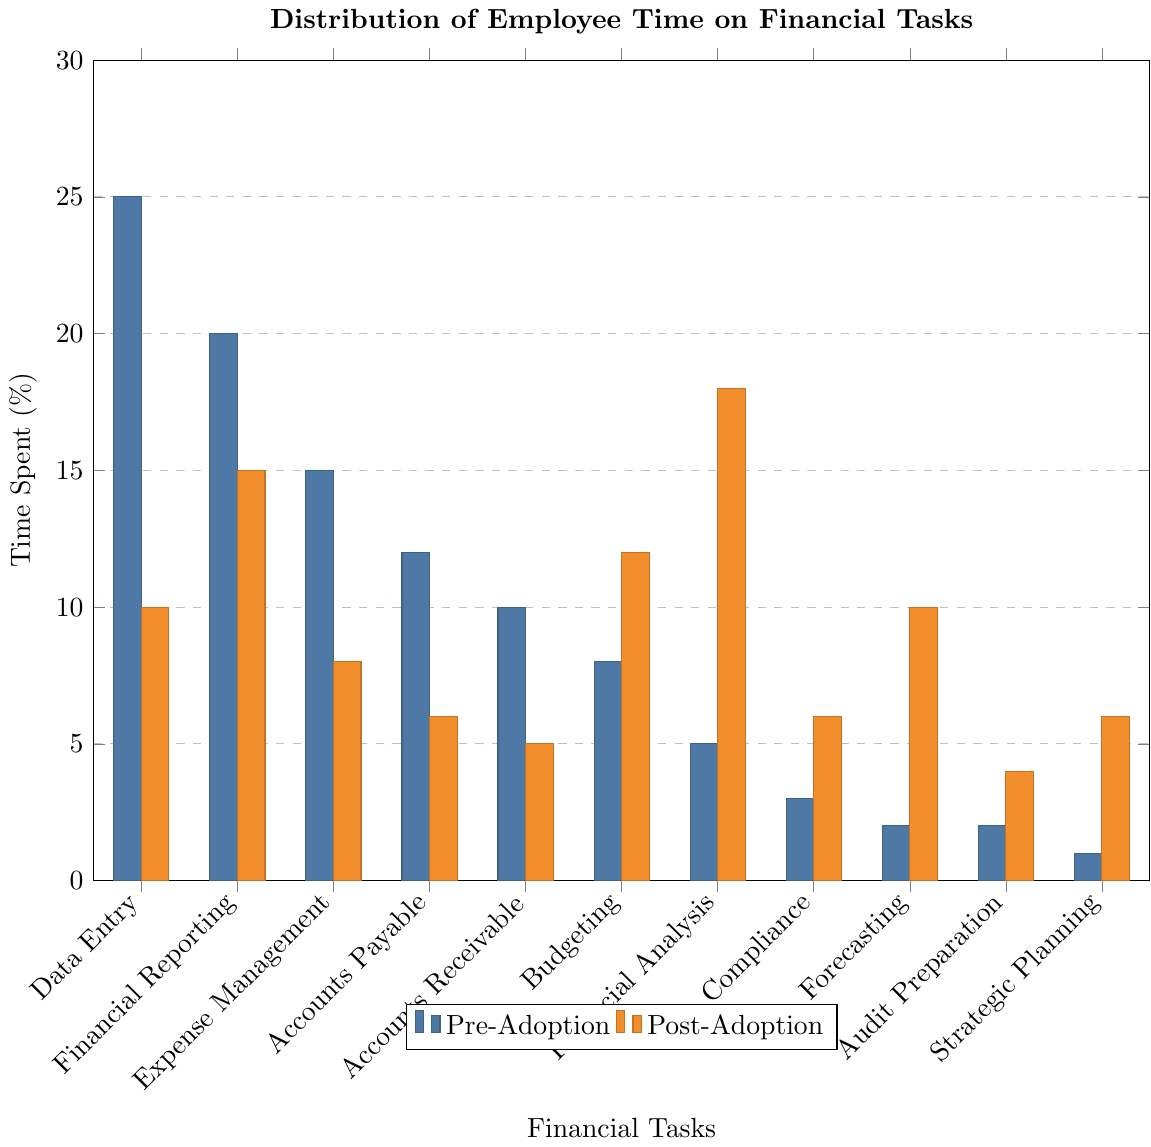What task saw the biggest decrease in time spent post-adoption? To determine the task with the biggest decrease, subtract the post-adoption percentage from the pre-adoption percentage for each task. The task with the largest positive difference is the answer. Data Entry: 25%-10%=15%, Financial Reporting: 20%-15%=5%, Expense Management: 15%-8%=7%, Accounts Payable: 12%-6%=6%, Accounts Receivable: 10%-5%=5%, Budgeting: 8%-12%=-4%, Financial Analysis: 5%-18%=-13%, Compliance: 3%-6%=-3%, Forecasting: 2%-10%=-8%, Audit Preparation: 2%-4%=-2%, Strategic Planning: 1%-6%=-5%. The largest positive value is 15% for Data Entry.
Answer: Data Entry Which tasks increased in percentage share of time spent post-adoption? Identify tasks where the post-adoption percentage is greater than the pre-adoption percentage. Financial Reporting: 20% -> 15% (-5%), Data Entry: 25% -> 10% (-15%), Expense Management: 15% -> 8% (-7%), Accounts Payable: 12% -> 6% (-6%), Accounts Receivable: 10% -> 5% (-5%), Budgeting: 8% -> 12% (+4%), Financial Analysis: 5% -> 18% (+13%), Compliance: 3% -> 6% (+3%), Forecasting: 2% -> 10% (+8%), Audit Preparation: 2% -> 4% (+2%), Strategic Planning: 1% -> 6% (+5%). Increased tasks are Budgeting, Financial Analysis, Compliance, Forecasting, Audit Preparation, and Strategic Planning.
Answer: Budgeting, Financial Analysis, Compliance, Forecasting, Audit Preparation, Strategic Planning Which task had the largest relative increase in time spent post-adoption? Calculate the relative increase as (Post - Pre) / Pre for tasks with a positive increase. Budgeting: (12-8)/8=0.5, Financial Analysis: (18-5)/5=2.6, Compliance: (6-3)/3=1.0, Forecasting: (10-2)/2=4.0, Audit Preparation: (4-2)/2=1.0, Strategic Planning: (6-1)/1=5.0. Strategic Planning had the largest relative increase.
Answer: Strategic Planning Compare the time spent on Financial Reporting pre- and post-adoption. What is the difference? Subtract the post-adoption percentage from the pre-adoption percentage for Financial Reporting. The difference is 20% - 15% = 5%.
Answer: 5% What is the combined percentage of time spent on Compliance and Forecasting post-adoption? Add the post-adoption percentages for Compliance and Forecasting. Compliance: 6%, Forecasting: 10%, combined = 6% + 10% = 16%.
Answer: 16% How does the time spent on Financial Analysis change from pre- to post-adoption? Subtract the pre-adoption percentage from the post-adoption percentage for Financial Analysis. The change is 18% - 5% = 13%.
Answer: 13% What percentage of time is spent on Data Entry and Financial Reporting combined post-adoption? Add the post-adoption percentages for Data Entry and Financial Reporting. Data Entry: 10%, Financial Reporting: 15%, combined = 10% + 15% = 25%.
Answer: 25% Which financial task had a percentage share of time post-adoption greater than pre-adoption by exactly 5%? Identify tasks where the post-adoption percentage is 5% more than the pre-adoption percentage. Compliance: 6% - 3% = 3%, Forecasting: 10% - 2% = 8%, Budgeting: 12% - 8% = 4%, Financial Analysis: 18% - 5% = 13%, Audit Preparation: 4% - 2% = 2%, Strategic Planning: 6% - 1% = 5%. The task is Strategic Planning.
Answer: Strategic Planning 